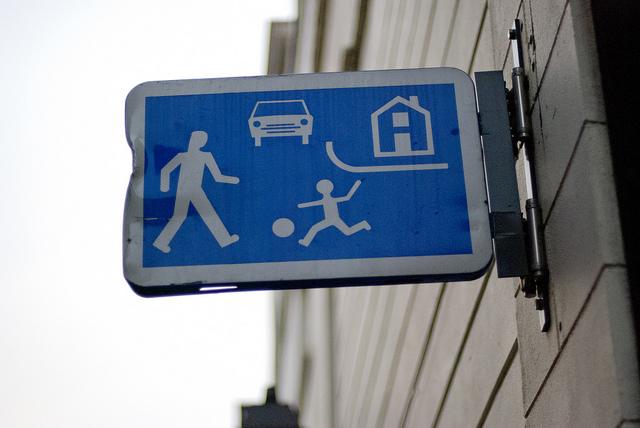What is the boy chasing on this sign?
Concise answer only. Ball. Where is the sign mounted?
Be succinct. Wall. What is the sign telling people?
Keep it brief. Children playing. What does the house symbol signify?
Answer briefly. Hotel. 